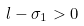Convert formula to latex. <formula><loc_0><loc_0><loc_500><loc_500>l - \sigma _ { 1 } > 0</formula> 